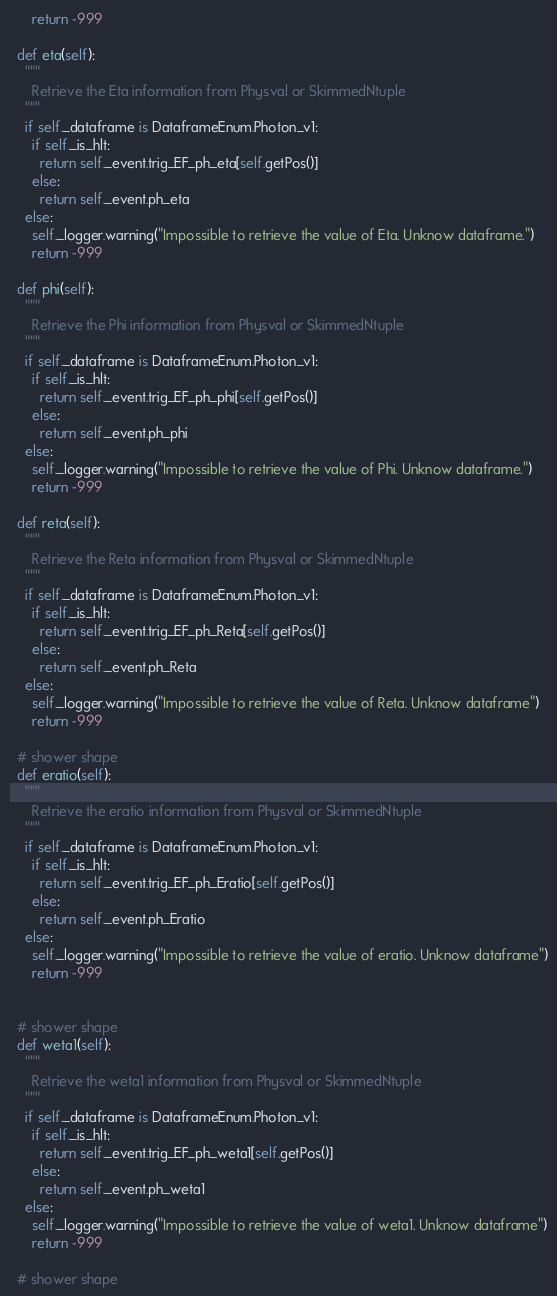Convert code to text. <code><loc_0><loc_0><loc_500><loc_500><_Python_>      return -999

  def eta(self):
    """
      Retrieve the Eta information from Physval or SkimmedNtuple
    """
    if self._dataframe is DataframeEnum.Photon_v1:
      if self._is_hlt:
        return self._event.trig_EF_ph_eta[self.getPos()]
      else:
        return self._event.ph_eta
    else:
      self._logger.warning("Impossible to retrieve the value of Eta. Unknow dataframe.")
      return -999

  def phi(self):
    """
      Retrieve the Phi information from Physval or SkimmedNtuple
    """
    if self._dataframe is DataframeEnum.Photon_v1:
      if self._is_hlt:
        return self._event.trig_EF_ph_phi[self.getPos()]
      else:
        return self._event.ph_phi
    else:
      self._logger.warning("Impossible to retrieve the value of Phi. Unknow dataframe.")
      return -999

  def reta(self):
    """
      Retrieve the Reta information from Physval or SkimmedNtuple
    """
    if self._dataframe is DataframeEnum.Photon_v1:
      if self._is_hlt:
        return self._event.trig_EF_ph_Reta[self.getPos()]
      else:
        return self._event.ph_Reta
    else:
      self._logger.warning("Impossible to retrieve the value of Reta. Unknow dataframe")
      return -999

  # shower shape
  def eratio(self):
    """
      Retrieve the eratio information from Physval or SkimmedNtuple
    """
    if self._dataframe is DataframeEnum.Photon_v1:
      if self._is_hlt:
        return self._event.trig_EF_ph_Eratio[self.getPos()]
      else:
        return self._event.ph_Eratio
    else:
      self._logger.warning("Impossible to retrieve the value of eratio. Unknow dataframe")
      return -999


  # shower shape
  def weta1(self):
    """
      Retrieve the weta1 information from Physval or SkimmedNtuple
    """
    if self._dataframe is DataframeEnum.Photon_v1:
      if self._is_hlt:
        return self._event.trig_EF_ph_weta1[self.getPos()]
      else:
        return self._event.ph_weta1
    else:
      self._logger.warning("Impossible to retrieve the value of weta1. Unknow dataframe")
      return -999

  # shower shape</code> 